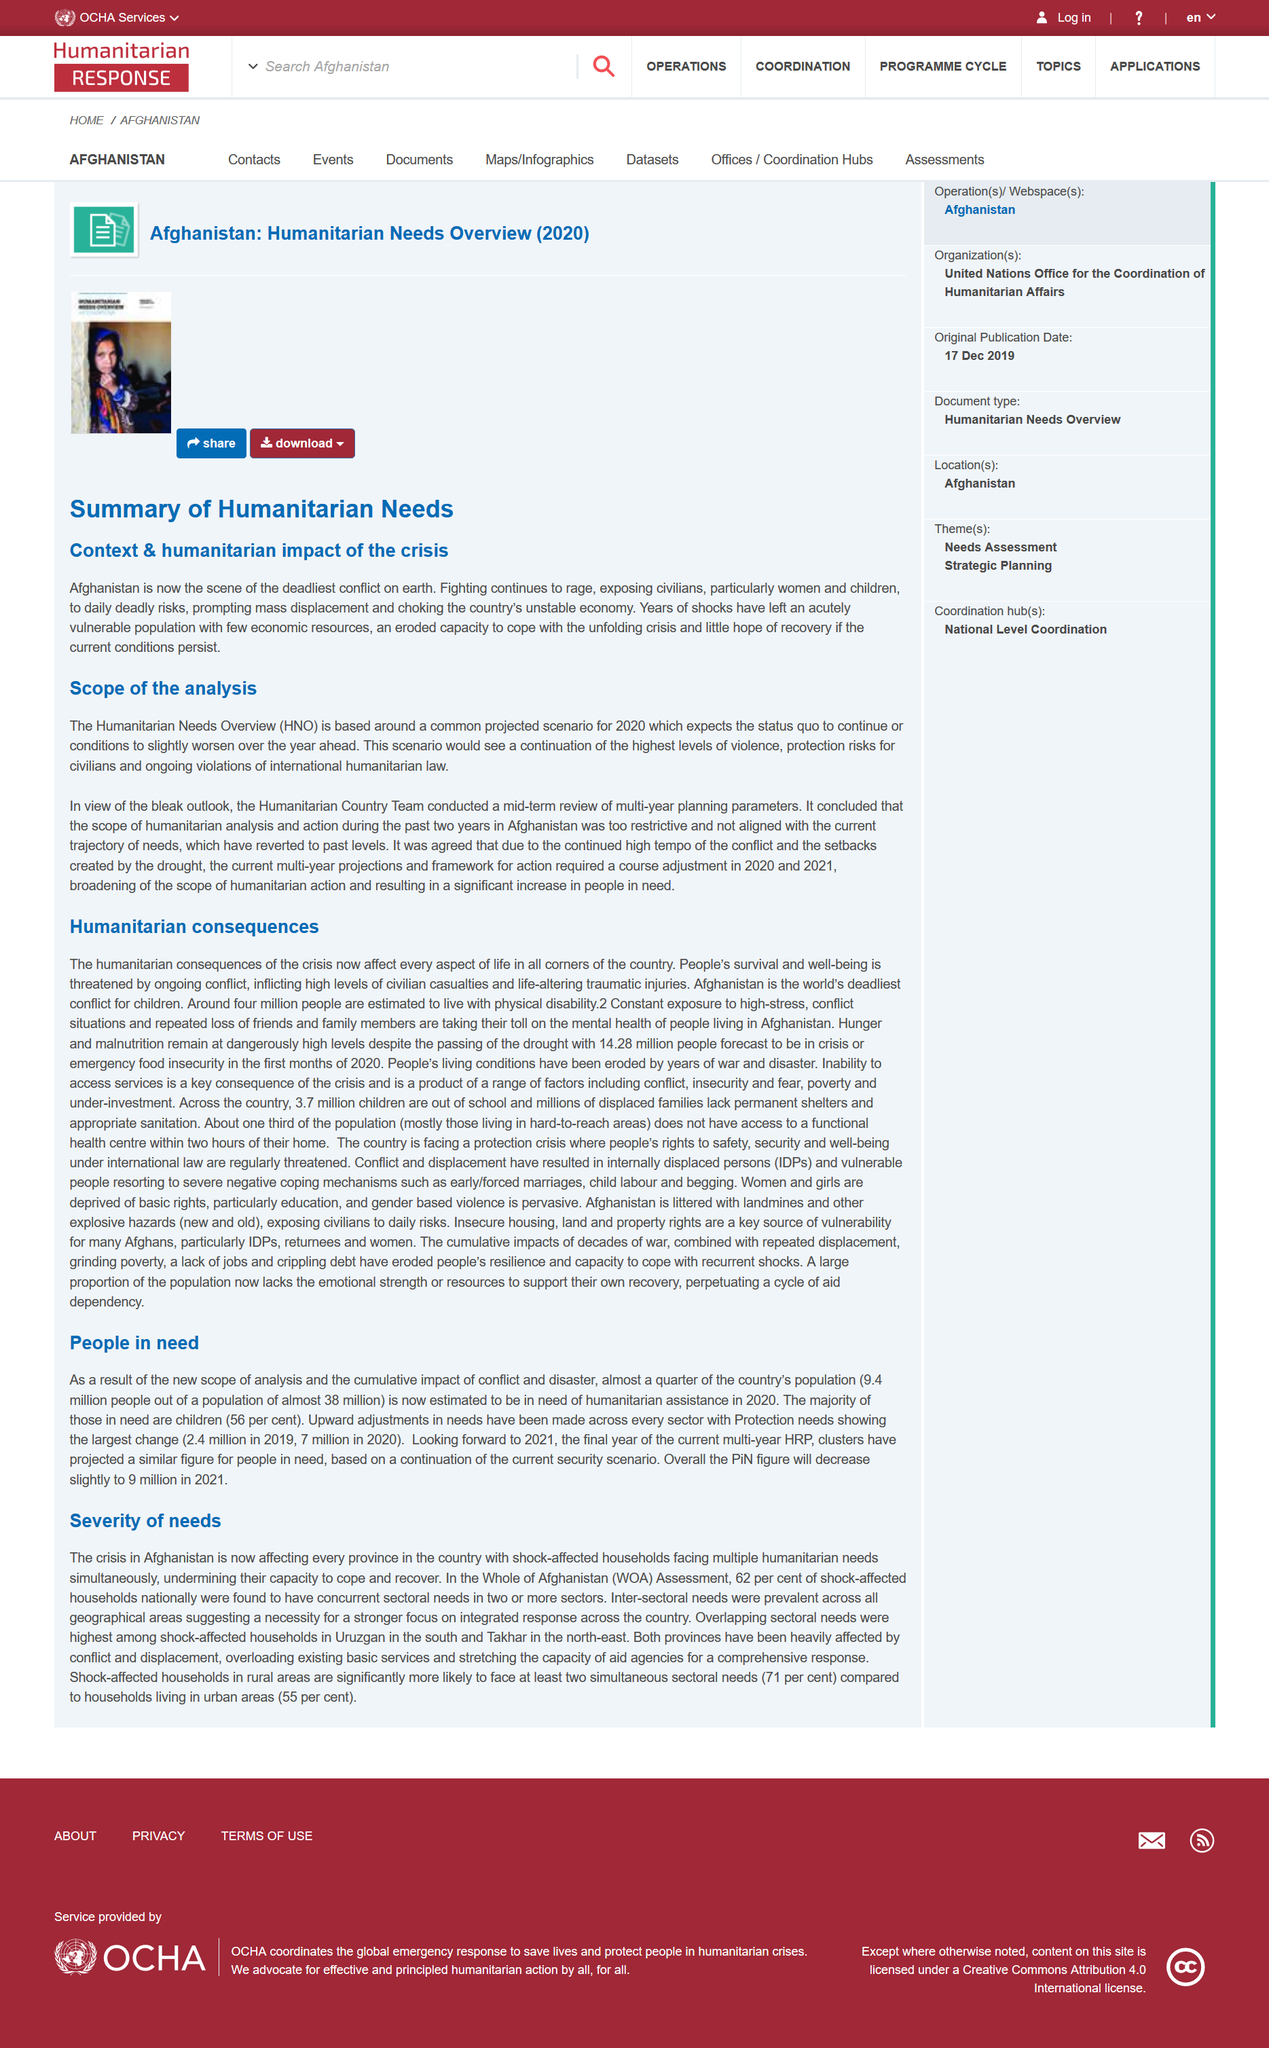Indicate a few pertinent items in this graphic. The acronym "HNO" stands for "Humanitarian Needs Overview. The deadliest conflict on earth is taking place in Afghanistan, according to the summary. There are two sections in this summary: "Context & humanitarian impact of the crisis" and "Scope of the analysis. 